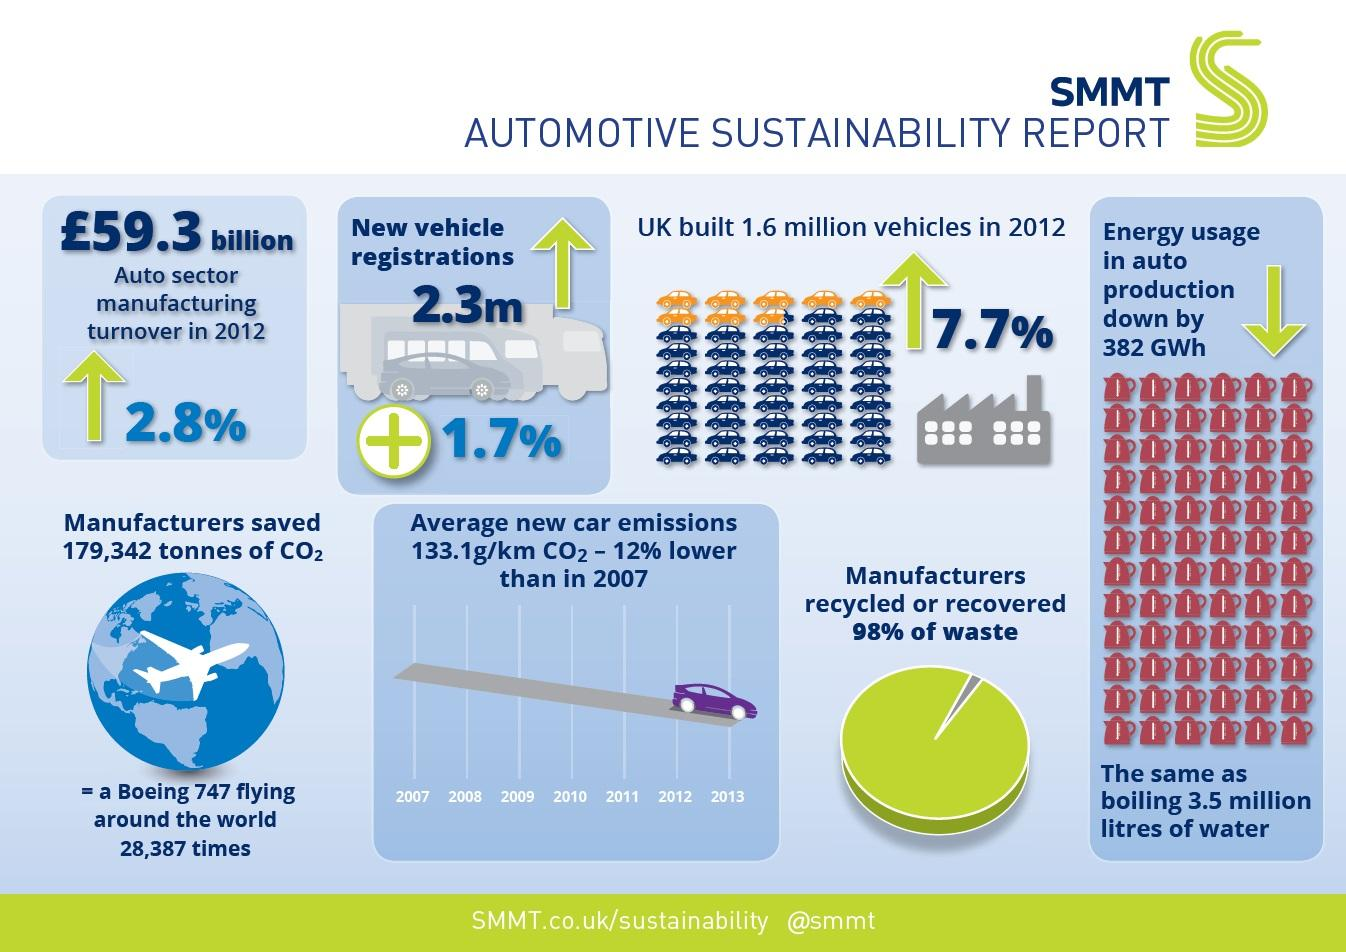Outline some significant characteristics in this image. The percentage increase in the registration of new vehicles was 1.7%, which was lower than the increases of 7.7% and 2.8%. In 2013, the emissions from cars were at their lowest level. 